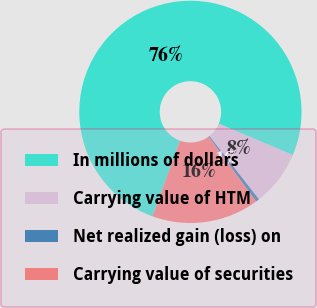<chart> <loc_0><loc_0><loc_500><loc_500><pie_chart><fcel>In millions of dollars<fcel>Carrying value of HTM<fcel>Net realized gain (loss) on<fcel>Carrying value of securities<nl><fcel>75.83%<fcel>8.06%<fcel>0.53%<fcel>15.59%<nl></chart> 